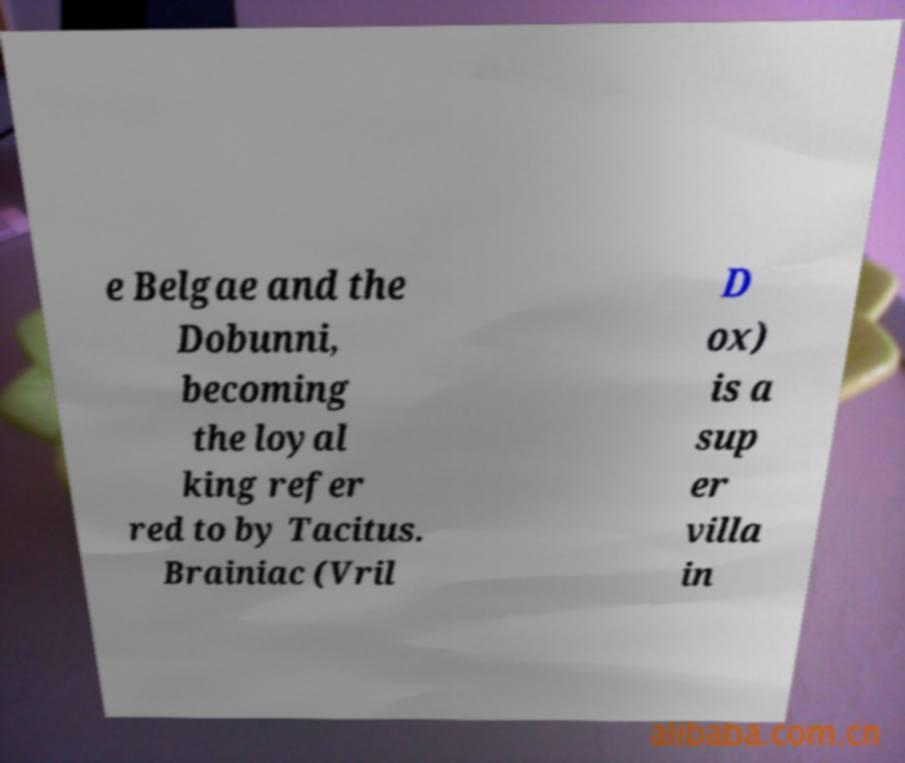I need the written content from this picture converted into text. Can you do that? e Belgae and the Dobunni, becoming the loyal king refer red to by Tacitus. Brainiac (Vril D ox) is a sup er villa in 